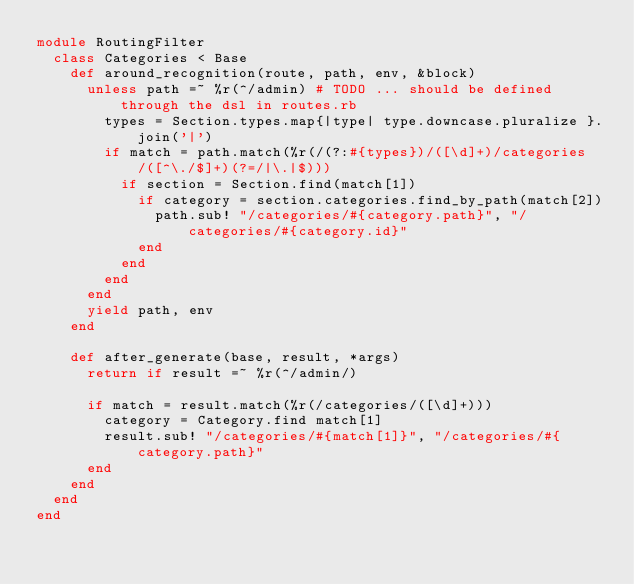<code> <loc_0><loc_0><loc_500><loc_500><_Ruby_>module RoutingFilter
  class Categories < Base
    def around_recognition(route, path, env, &block)
      unless path =~ %r(^/admin) # TODO ... should be defined through the dsl in routes.rb
        types = Section.types.map{|type| type.downcase.pluralize }.join('|')
        if match = path.match(%r(/(?:#{types})/([\d]+)/categories/([^\./$]+)(?=/|\.|$)))
          if section = Section.find(match[1])
            if category = section.categories.find_by_path(match[2])
              path.sub! "/categories/#{category.path}", "/categories/#{category.id}"
            end
          end
        end
      end
      yield path, env
    end

    def after_generate(base, result, *args)
      return if result =~ %r(^/admin/)

      if match = result.match(%r(/categories/([\d]+)))
        category = Category.find match[1]
        result.sub! "/categories/#{match[1]}", "/categories/#{category.path}"
      end
    end
  end
end
</code> 